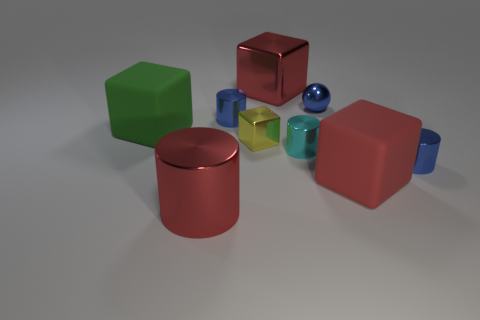Subtract all green cylinders. Subtract all gray blocks. How many cylinders are left? 4 Add 1 big blue shiny cylinders. How many objects exist? 10 Subtract all spheres. How many objects are left? 8 Add 4 spheres. How many spheres are left? 5 Add 1 green rubber blocks. How many green rubber blocks exist? 2 Subtract 0 cyan blocks. How many objects are left? 9 Subtract all cubes. Subtract all small blue balls. How many objects are left? 4 